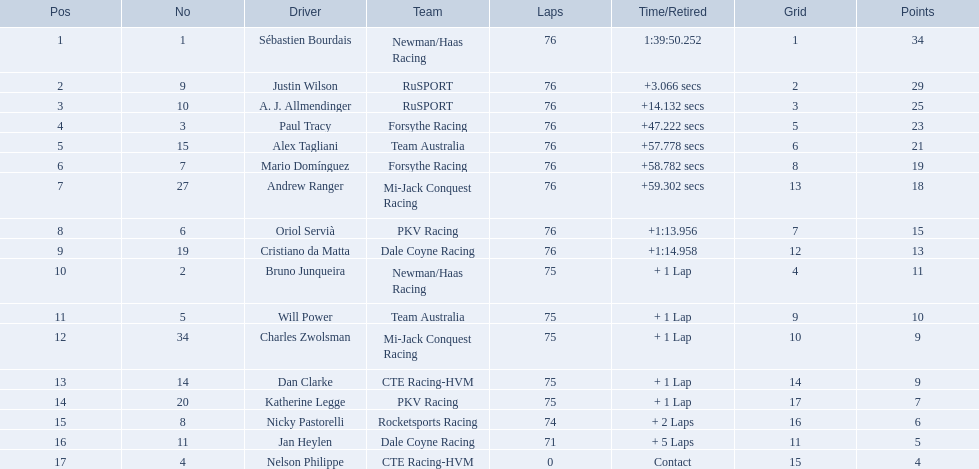What drivers took part in the 2006 tecate grand prix of monterrey? Sébastien Bourdais, Justin Wilson, A. J. Allmendinger, Paul Tracy, Alex Tagliani, Mario Domínguez, Andrew Ranger, Oriol Servià, Cristiano da Matta, Bruno Junqueira, Will Power, Charles Zwolsman, Dan Clarke, Katherine Legge, Nicky Pastorelli, Jan Heylen, Nelson Philippe. Which of those drivers scored the same amount of points as another driver? Charles Zwolsman, Dan Clarke. Who had the same amount of points as charles zwolsman? Dan Clarke. Who participated in the 2006 tecate grand prix of monterrey? Sébastien Bourdais, Justin Wilson, A. J. Allmendinger, Paul Tracy, Alex Tagliani, Mario Domínguez, Andrew Ranger, Oriol Servià, Cristiano da Matta, Bruno Junqueira, Will Power, Charles Zwolsman, Dan Clarke, Katherine Legge, Nicky Pastorelli, Jan Heylen, Nelson Philippe. And what were their final standings? 1, 2, 3, 4, 5, 6, 7, 8, 9, 10, 11, 12, 13, 14, 15, 16, 17. Who was immediately ahead of alex tagliani? Paul Tracy. 